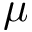Convert formula to latex. <formula><loc_0><loc_0><loc_500><loc_500>\mu</formula> 